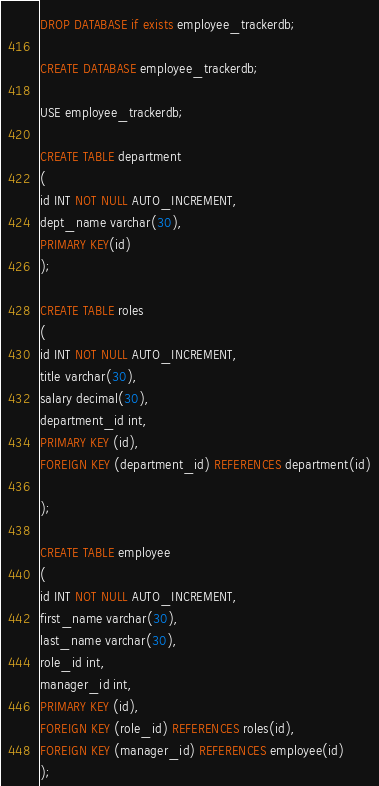Convert code to text. <code><loc_0><loc_0><loc_500><loc_500><_SQL_>DROP DATABASE if exists employee_trackerdb;

CREATE DATABASE employee_trackerdb;

USE employee_trackerdb;

CREATE TABLE department
(
id INT NOT NULL AUTO_INCREMENT,
dept_name varchar(30),
PRIMARY KEY(id)
);

CREATE TABLE roles
(
id INT NOT NULL AUTO_INCREMENT,
title varchar(30),
salary decimal(30),
department_id int,
PRIMARY KEY (id),
FOREIGN KEY (department_id) REFERENCES department(id)

);

CREATE TABLE employee
(
id INT NOT NULL AUTO_INCREMENT,
first_name varchar(30),
last_name varchar(30),
role_id int,
manager_id int,
PRIMARY KEY (id),
FOREIGN KEY (role_id) REFERENCES roles(id),
FOREIGN KEY (manager_id) REFERENCES employee(id)
);




</code> 